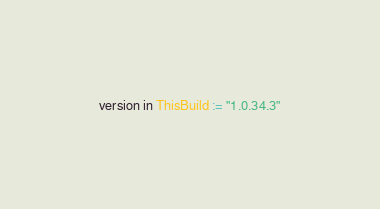Convert code to text. <code><loc_0><loc_0><loc_500><loc_500><_Scala_>version in ThisBuild := "1.0.34.3"
</code> 